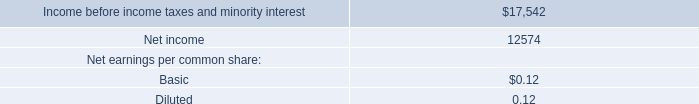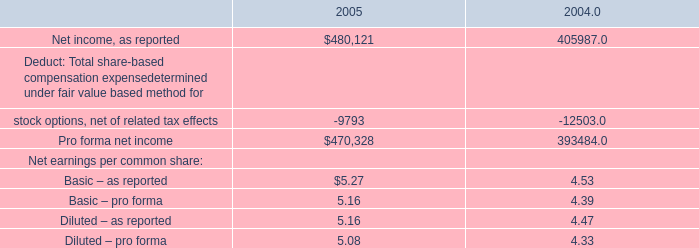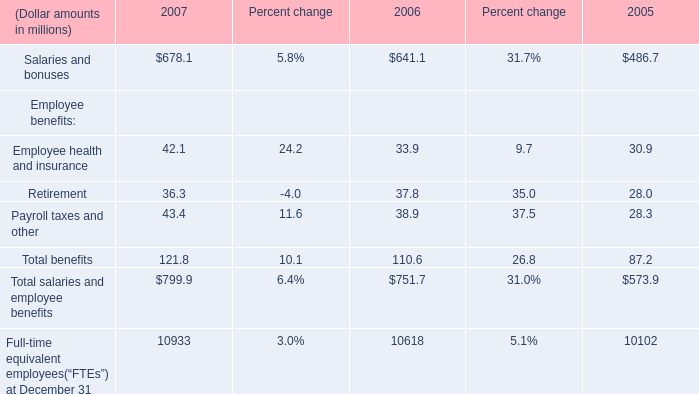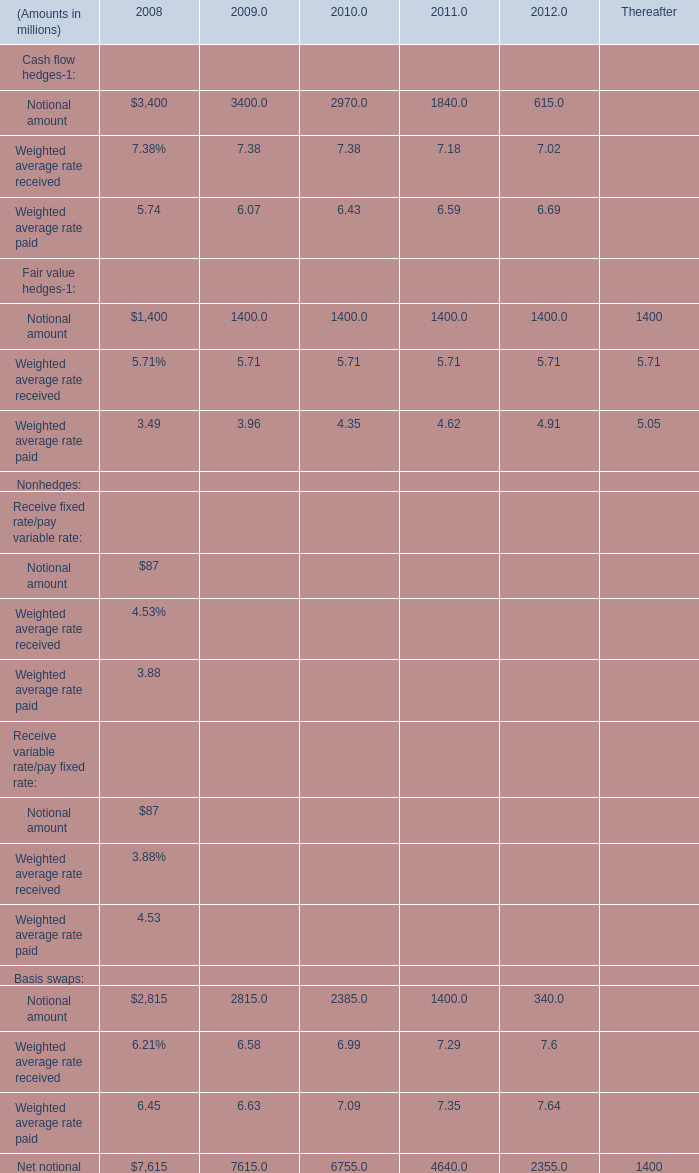What was the average of the Basis swaps: Notional amount in the years where Cash flow hedges-1: Notional amount is positive? (in million) 
Computations: (((((2815 + 2815) + 2385) + 1400) + 340) / 5)
Answer: 1951.0. 